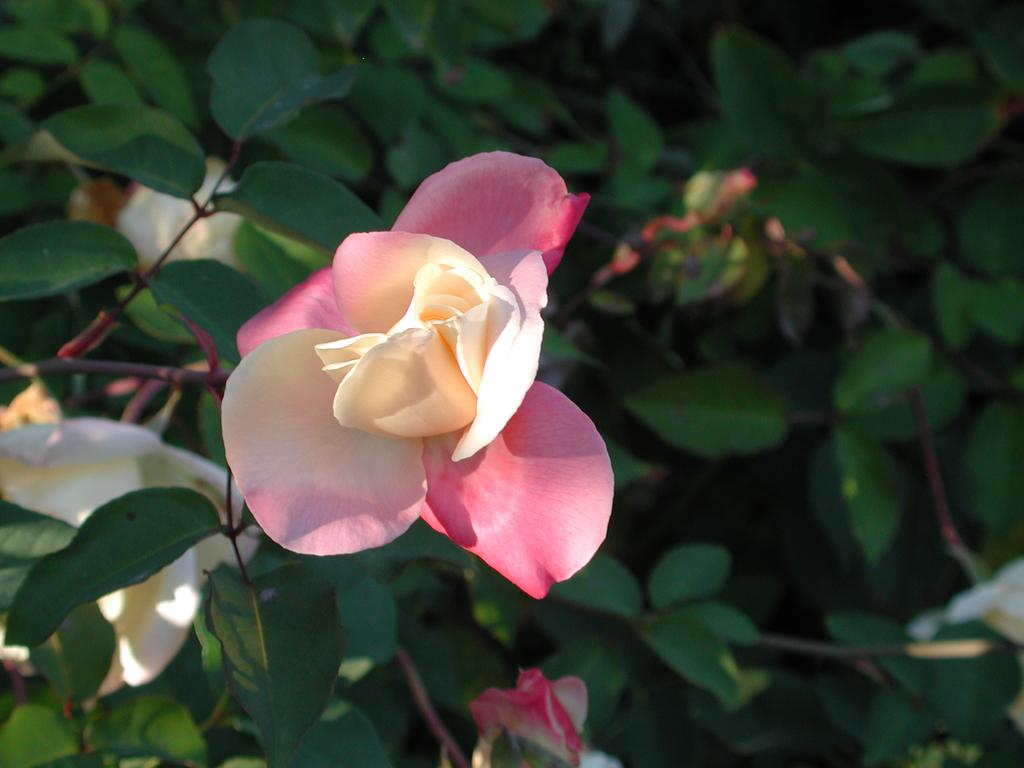What type of flower is in the image? There is a rose flower in the image. Where is the rose flower located? The rose flower is on a rose plant. What other parts of the plant can be seen in the image? There are flower buds around the plant. How is the background of the image presented? The background of the plant is blurred. What grade does the sweater receive in the image? There is no sweater present in the image, so it cannot receive a grade. 